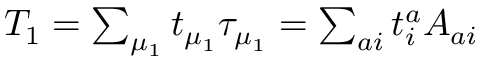<formula> <loc_0><loc_0><loc_500><loc_500>\begin{array} { r } { T _ { 1 } = \sum _ { \mu _ { 1 } } t _ { \mu _ { 1 } } \tau _ { \mu _ { 1 } } = \sum _ { a i } t _ { i } ^ { a } A _ { a i } } \end{array}</formula> 